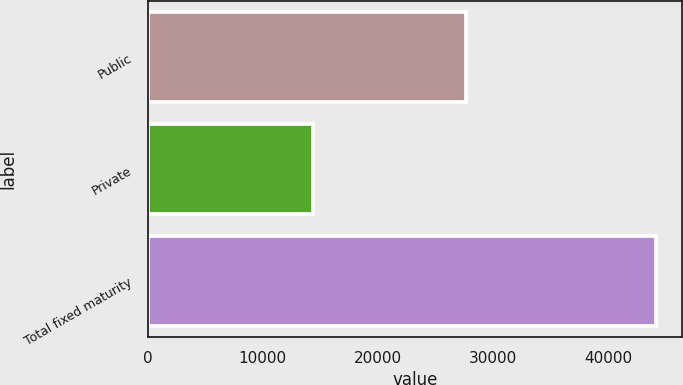<chart> <loc_0><loc_0><loc_500><loc_500><bar_chart><fcel>Public<fcel>Private<fcel>Total fixed maturity<nl><fcel>27623.6<fcel>14371.1<fcel>44193.5<nl></chart> 